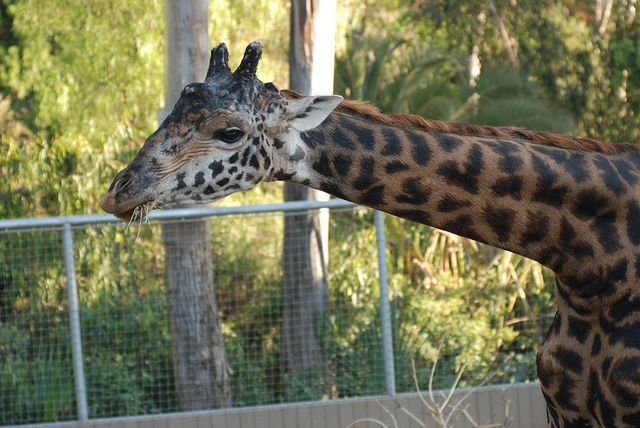Describe the objects in this image and their specific colors. I can see a giraffe in black, gray, and maroon tones in this image. 